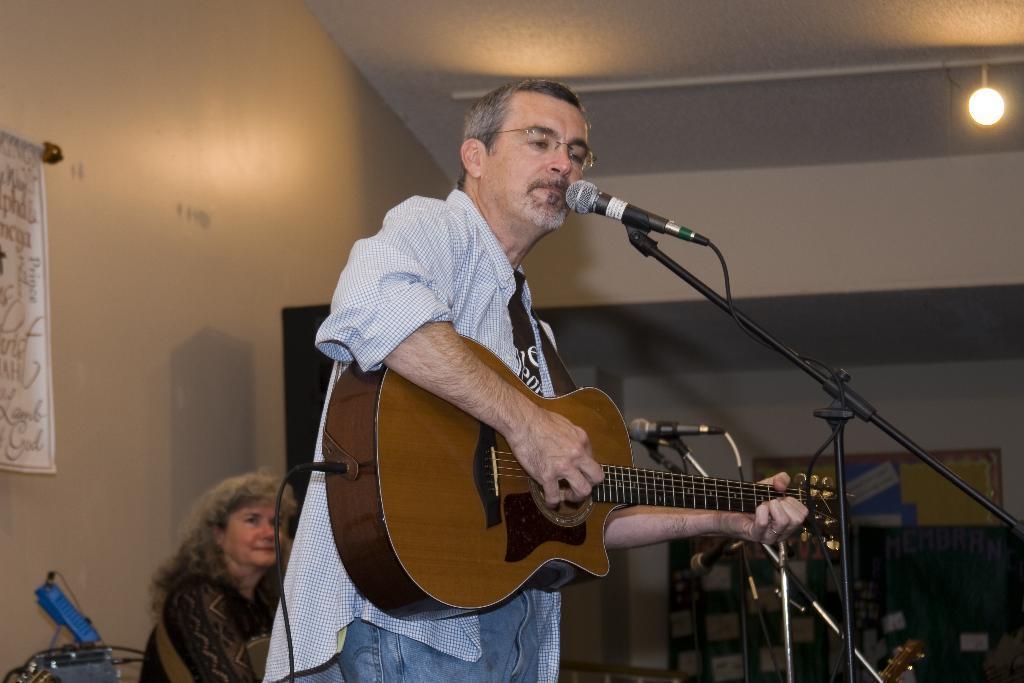Please provide a concise description of this image. Front this person is playing a guitar and singing in-front of a mic. This is a mic with holder. On top there is a light. This woman is sitting. Poster is on wall. 